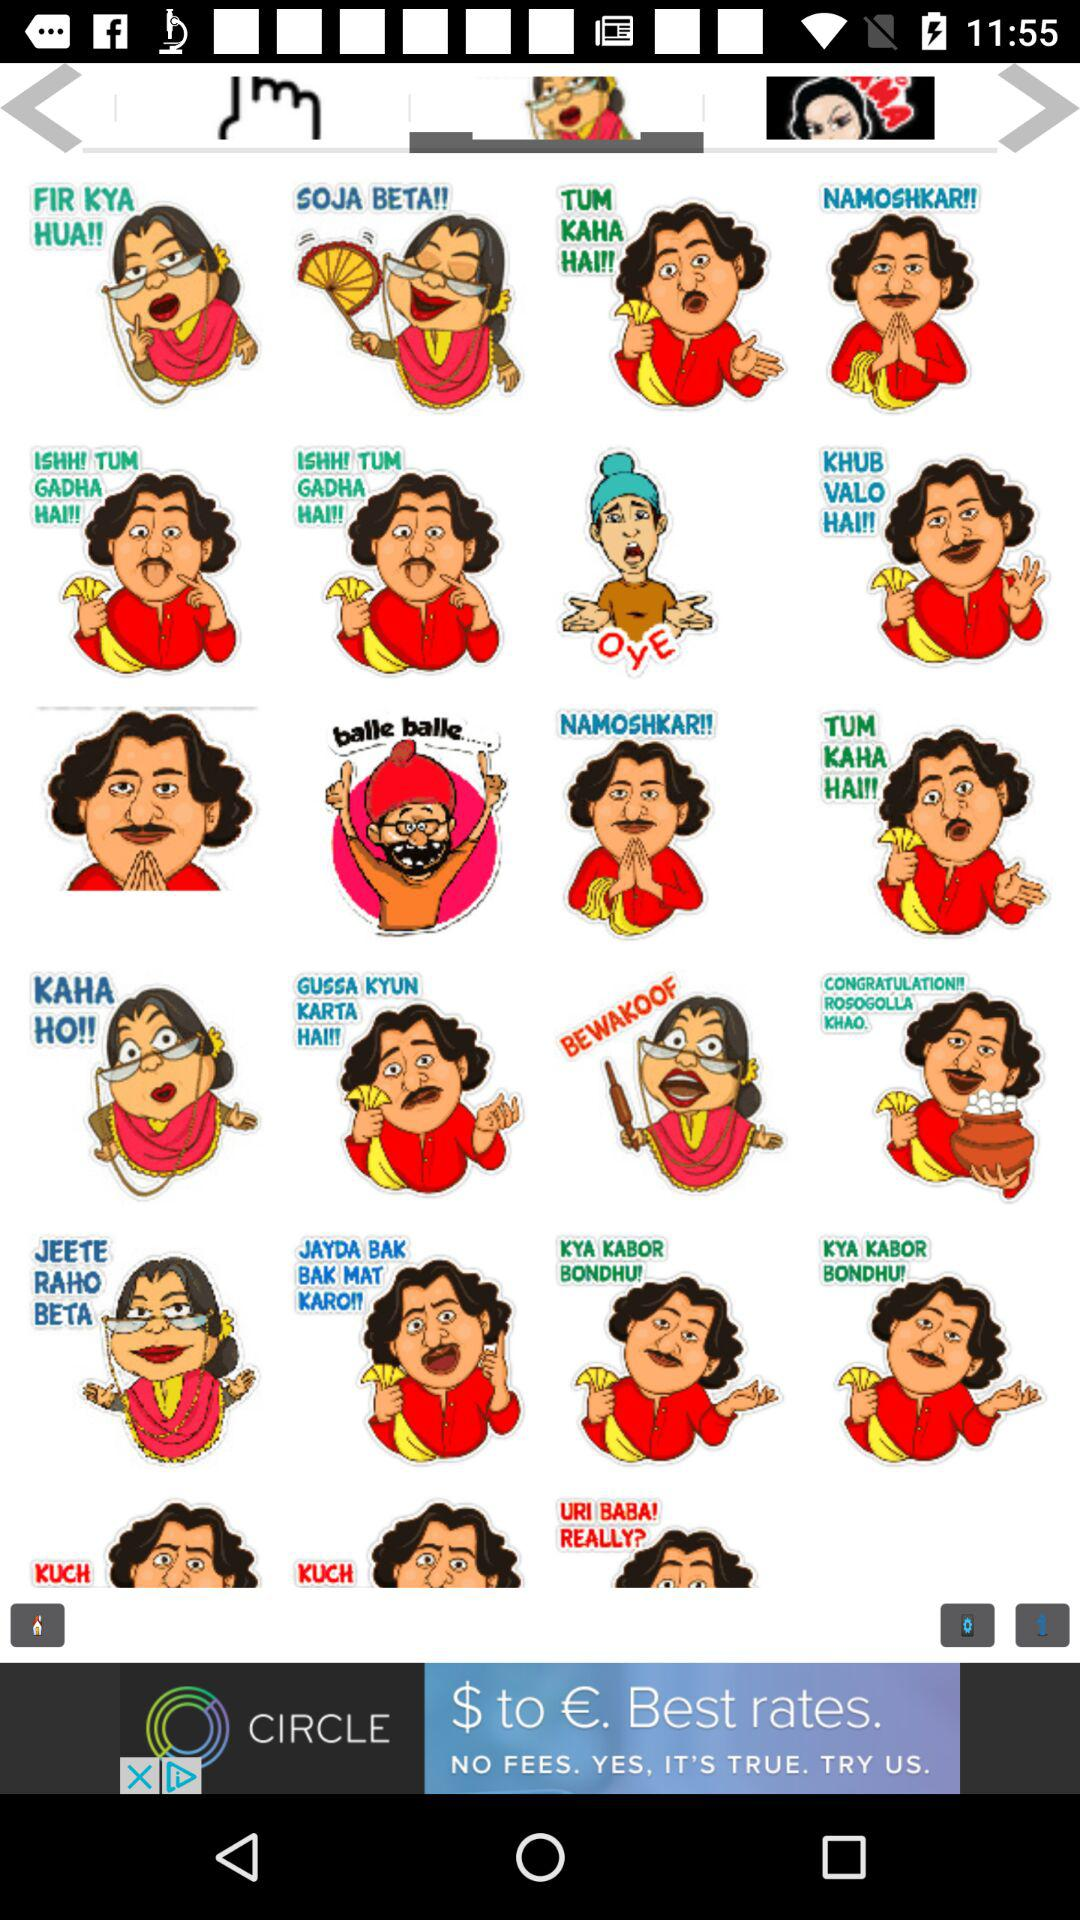How many stickers are there in the third row?
Answer the question using a single word or phrase. 4 